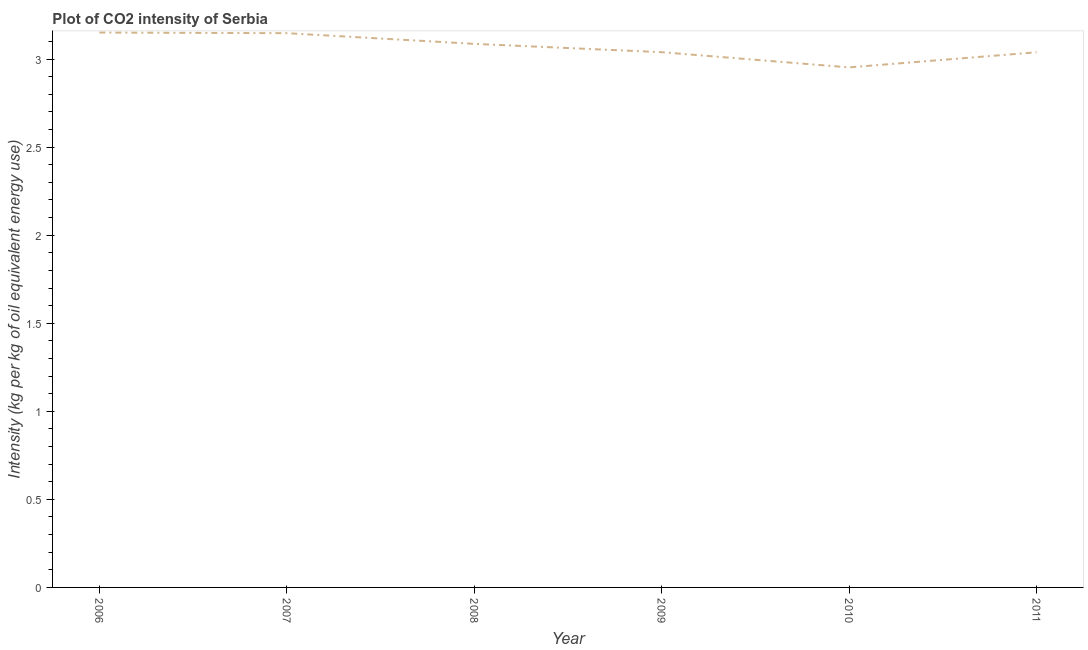What is the co2 intensity in 2008?
Offer a terse response. 3.09. Across all years, what is the maximum co2 intensity?
Make the answer very short. 3.15. Across all years, what is the minimum co2 intensity?
Offer a terse response. 2.95. In which year was the co2 intensity minimum?
Ensure brevity in your answer.  2010. What is the sum of the co2 intensity?
Provide a succinct answer. 18.42. What is the difference between the co2 intensity in 2008 and 2011?
Your answer should be compact. 0.05. What is the average co2 intensity per year?
Keep it short and to the point. 3.07. What is the median co2 intensity?
Provide a succinct answer. 3.06. In how many years, is the co2 intensity greater than 1.1 kg?
Your answer should be compact. 6. Do a majority of the years between 2011 and 2008 (inclusive) have co2 intensity greater than 2.1 kg?
Your answer should be very brief. Yes. What is the ratio of the co2 intensity in 2008 to that in 2010?
Ensure brevity in your answer.  1.05. What is the difference between the highest and the second highest co2 intensity?
Offer a terse response. 0. Is the sum of the co2 intensity in 2009 and 2010 greater than the maximum co2 intensity across all years?
Offer a very short reply. Yes. What is the difference between the highest and the lowest co2 intensity?
Keep it short and to the point. 0.2. In how many years, is the co2 intensity greater than the average co2 intensity taken over all years?
Make the answer very short. 3. How many years are there in the graph?
Offer a very short reply. 6. What is the difference between two consecutive major ticks on the Y-axis?
Provide a succinct answer. 0.5. Are the values on the major ticks of Y-axis written in scientific E-notation?
Make the answer very short. No. What is the title of the graph?
Ensure brevity in your answer.  Plot of CO2 intensity of Serbia. What is the label or title of the Y-axis?
Keep it short and to the point. Intensity (kg per kg of oil equivalent energy use). What is the Intensity (kg per kg of oil equivalent energy use) of 2006?
Offer a very short reply. 3.15. What is the Intensity (kg per kg of oil equivalent energy use) in 2007?
Your answer should be very brief. 3.15. What is the Intensity (kg per kg of oil equivalent energy use) of 2008?
Provide a short and direct response. 3.09. What is the Intensity (kg per kg of oil equivalent energy use) in 2009?
Your answer should be compact. 3.04. What is the Intensity (kg per kg of oil equivalent energy use) in 2010?
Keep it short and to the point. 2.95. What is the Intensity (kg per kg of oil equivalent energy use) of 2011?
Provide a succinct answer. 3.04. What is the difference between the Intensity (kg per kg of oil equivalent energy use) in 2006 and 2007?
Provide a short and direct response. 0. What is the difference between the Intensity (kg per kg of oil equivalent energy use) in 2006 and 2008?
Give a very brief answer. 0.06. What is the difference between the Intensity (kg per kg of oil equivalent energy use) in 2006 and 2009?
Your answer should be compact. 0.11. What is the difference between the Intensity (kg per kg of oil equivalent energy use) in 2006 and 2010?
Your response must be concise. 0.2. What is the difference between the Intensity (kg per kg of oil equivalent energy use) in 2006 and 2011?
Ensure brevity in your answer.  0.11. What is the difference between the Intensity (kg per kg of oil equivalent energy use) in 2007 and 2008?
Your response must be concise. 0.06. What is the difference between the Intensity (kg per kg of oil equivalent energy use) in 2007 and 2009?
Offer a terse response. 0.11. What is the difference between the Intensity (kg per kg of oil equivalent energy use) in 2007 and 2010?
Provide a succinct answer. 0.19. What is the difference between the Intensity (kg per kg of oil equivalent energy use) in 2007 and 2011?
Keep it short and to the point. 0.11. What is the difference between the Intensity (kg per kg of oil equivalent energy use) in 2008 and 2009?
Offer a very short reply. 0.05. What is the difference between the Intensity (kg per kg of oil equivalent energy use) in 2008 and 2010?
Make the answer very short. 0.13. What is the difference between the Intensity (kg per kg of oil equivalent energy use) in 2008 and 2011?
Provide a succinct answer. 0.05. What is the difference between the Intensity (kg per kg of oil equivalent energy use) in 2009 and 2010?
Keep it short and to the point. 0.09. What is the difference between the Intensity (kg per kg of oil equivalent energy use) in 2009 and 2011?
Make the answer very short. 0. What is the difference between the Intensity (kg per kg of oil equivalent energy use) in 2010 and 2011?
Ensure brevity in your answer.  -0.09. What is the ratio of the Intensity (kg per kg of oil equivalent energy use) in 2006 to that in 2008?
Your answer should be compact. 1.02. What is the ratio of the Intensity (kg per kg of oil equivalent energy use) in 2006 to that in 2009?
Keep it short and to the point. 1.04. What is the ratio of the Intensity (kg per kg of oil equivalent energy use) in 2006 to that in 2010?
Keep it short and to the point. 1.07. What is the ratio of the Intensity (kg per kg of oil equivalent energy use) in 2007 to that in 2009?
Offer a very short reply. 1.04. What is the ratio of the Intensity (kg per kg of oil equivalent energy use) in 2007 to that in 2010?
Ensure brevity in your answer.  1.07. What is the ratio of the Intensity (kg per kg of oil equivalent energy use) in 2007 to that in 2011?
Make the answer very short. 1.04. What is the ratio of the Intensity (kg per kg of oil equivalent energy use) in 2008 to that in 2009?
Provide a short and direct response. 1.02. What is the ratio of the Intensity (kg per kg of oil equivalent energy use) in 2008 to that in 2010?
Your answer should be very brief. 1.04. What is the ratio of the Intensity (kg per kg of oil equivalent energy use) in 2008 to that in 2011?
Make the answer very short. 1.02. What is the ratio of the Intensity (kg per kg of oil equivalent energy use) in 2010 to that in 2011?
Provide a short and direct response. 0.97. 